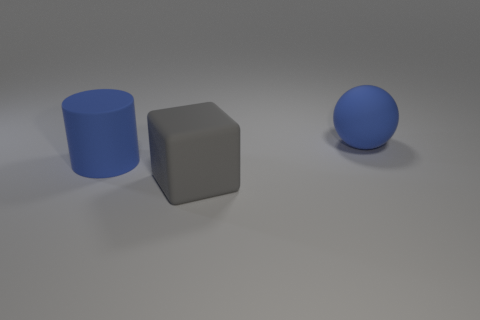What materials appear to be depicted in this image? The image seems to showcase objects with three different textures. The cylinder and sphere appear to have a rubbery texture and are colored blue, while the cube has a matte finish and is gray, suggesting a contrast in both color and material. 